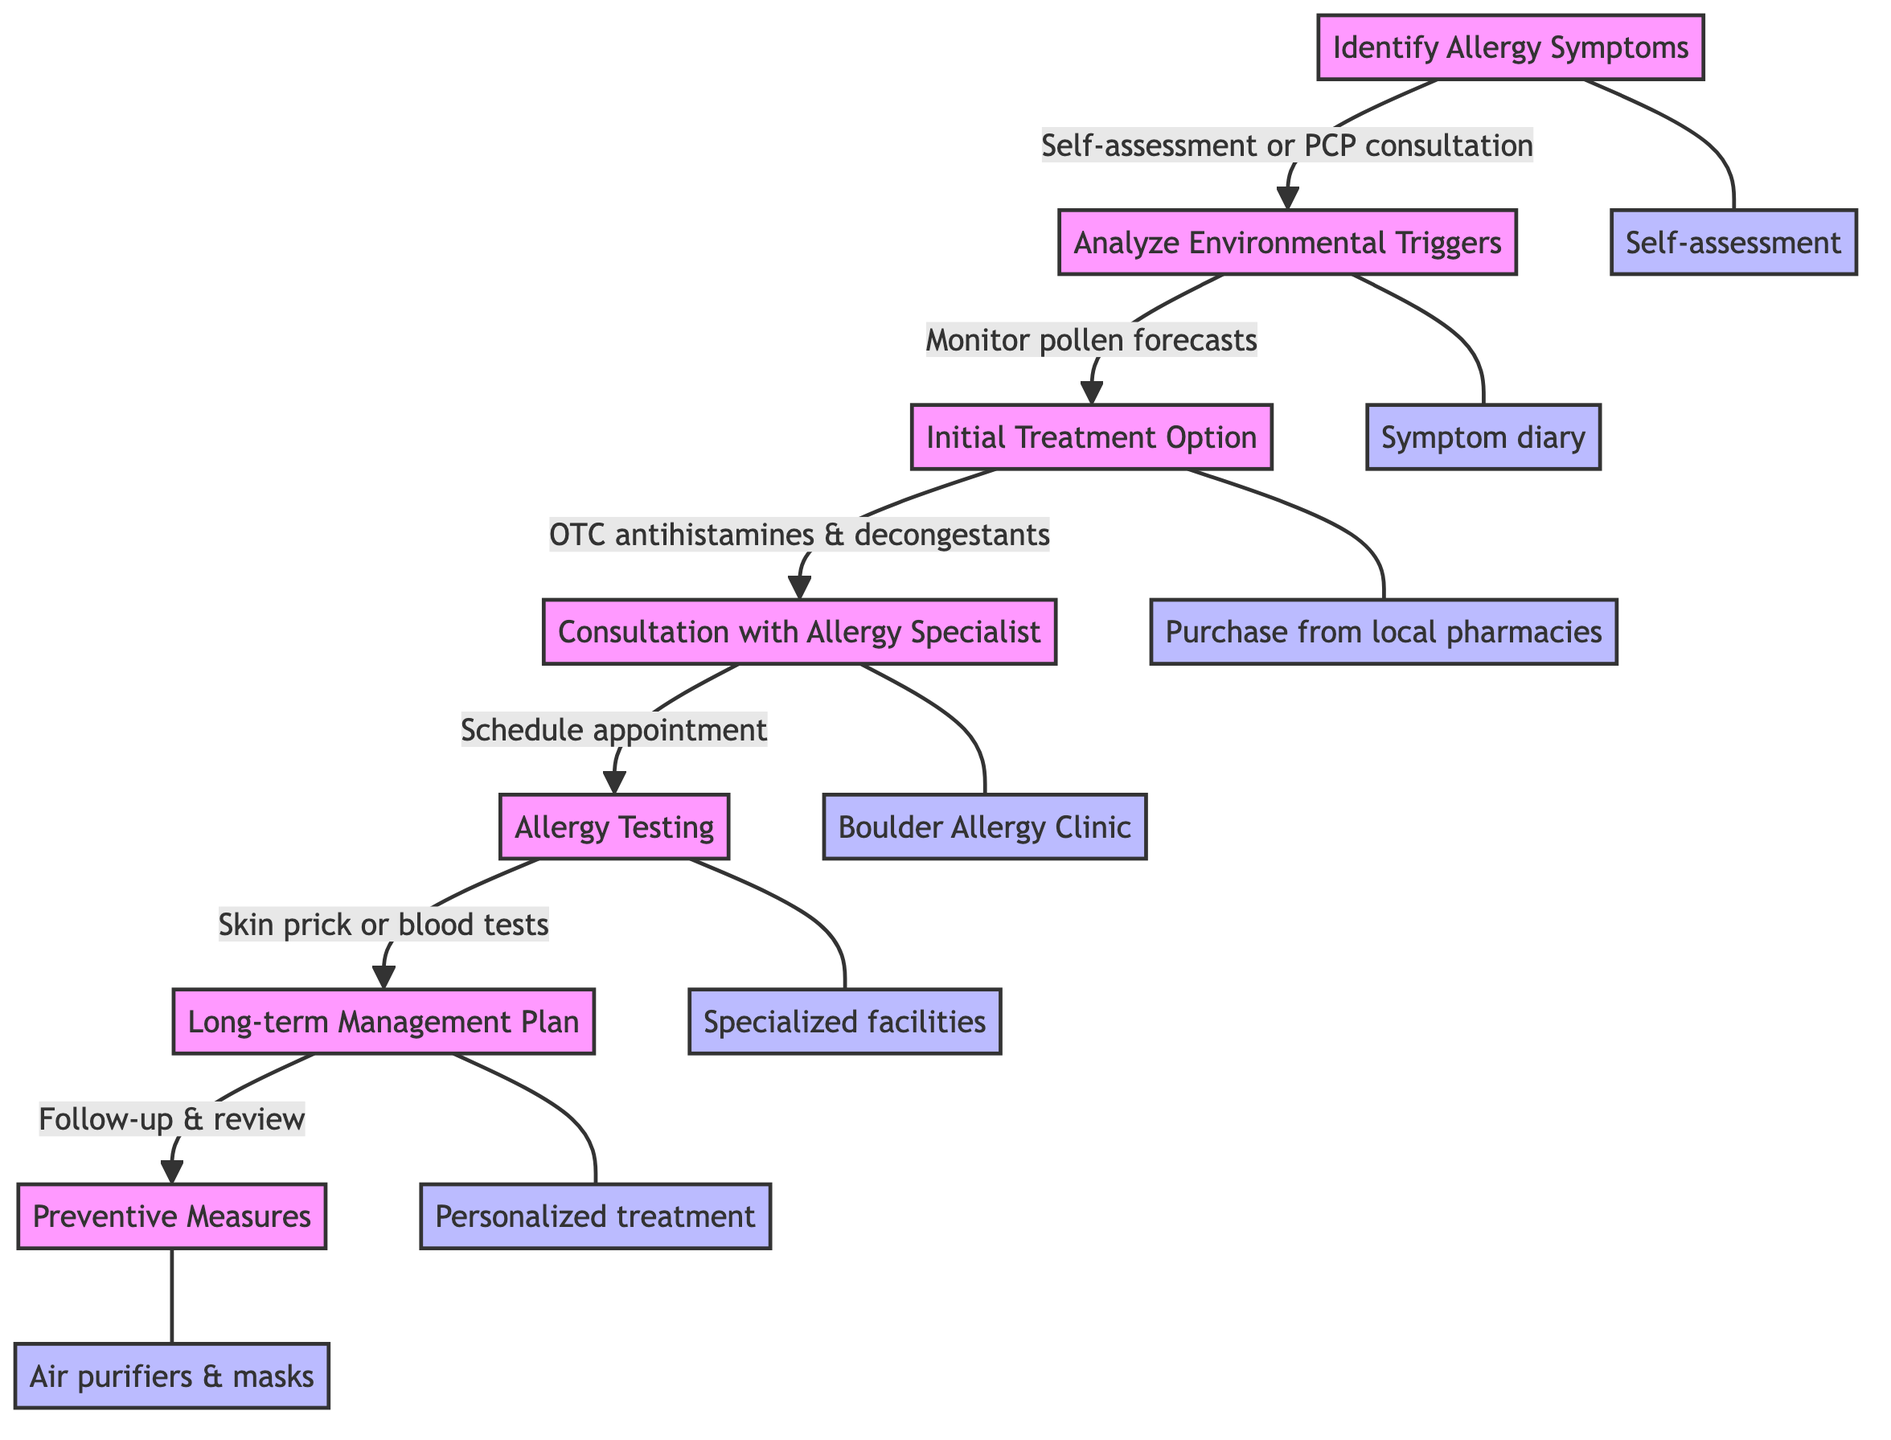What is the first step in the pathway? The first step outlined in the pathway is "Identify Allergy Symptoms," where individuals recognize symptoms such as sneezing and congestion.
Answer: Identify Allergy Symptoms How many steps are in the treatment pathway? Counting all the steps listed from "Identify Allergy Symptoms" to "Preventive Measures," there are a total of 7 steps in the pathway.
Answer: 7 What action is associated with "Consultation with Allergy Specialist"? The action associated with this step is "Schedule an appointment with providers like Boulder Allergy Clinic or Denver Allergy and Asthma Associates."
Answer: Schedule an appointment Which step follows "Initial Treatment Option"? The diagram shows that the step following "Initial Treatment Option" is "Consultation with Allergy Specialist."
Answer: Consultation with Allergy Specialist What preventive measures can be taken according to the last step? The last step refers to implementing changes such as using air purifiers and avoiding outdoor activities during peak pollen times.
Answer: Air purifiers and avoiding outdoor activities What is the purpose of conducting "Allergy Testing"? The purpose of conducting "Allergy Testing" is to identify specific allergens through skin prick tests or blood tests, as indicated in the pathway.
Answer: Identify specific allergens What are two common environmental triggers identified in the pathway? Two common environmental triggers mentioned are pollen from pine trees and grasses, according to the analysis step.
Answer: Pollen from pine trees and grasses What type of facilities administer "Allergy Testing"? The pathway specifies that "Allergy Testing" is administered at specialized facilities, as recommended by the allergy specialist.
Answer: Specialized facilities Why is a symptom diary recommended in the second step? A symptom diary is recommended to help identify environmental triggers and monitor local pollen forecasts, which is crucial for managing seasonal allergies.
Answer: Identify environmental triggers and monitor pollen forecasts 